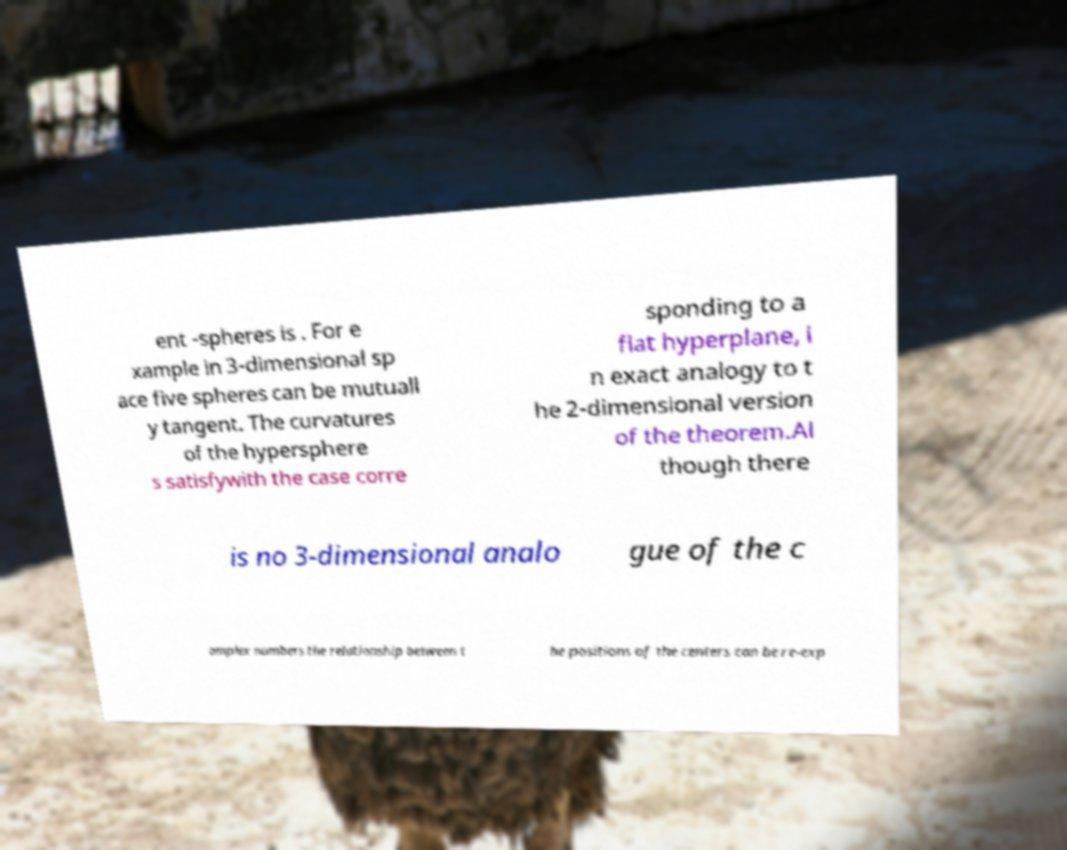Could you assist in decoding the text presented in this image and type it out clearly? ent -spheres is . For e xample in 3-dimensional sp ace five spheres can be mutuall y tangent. The curvatures of the hypersphere s satisfywith the case corre sponding to a flat hyperplane, i n exact analogy to t he 2-dimensional version of the theorem.Al though there is no 3-dimensional analo gue of the c omplex numbers the relationship between t he positions of the centers can be re-exp 